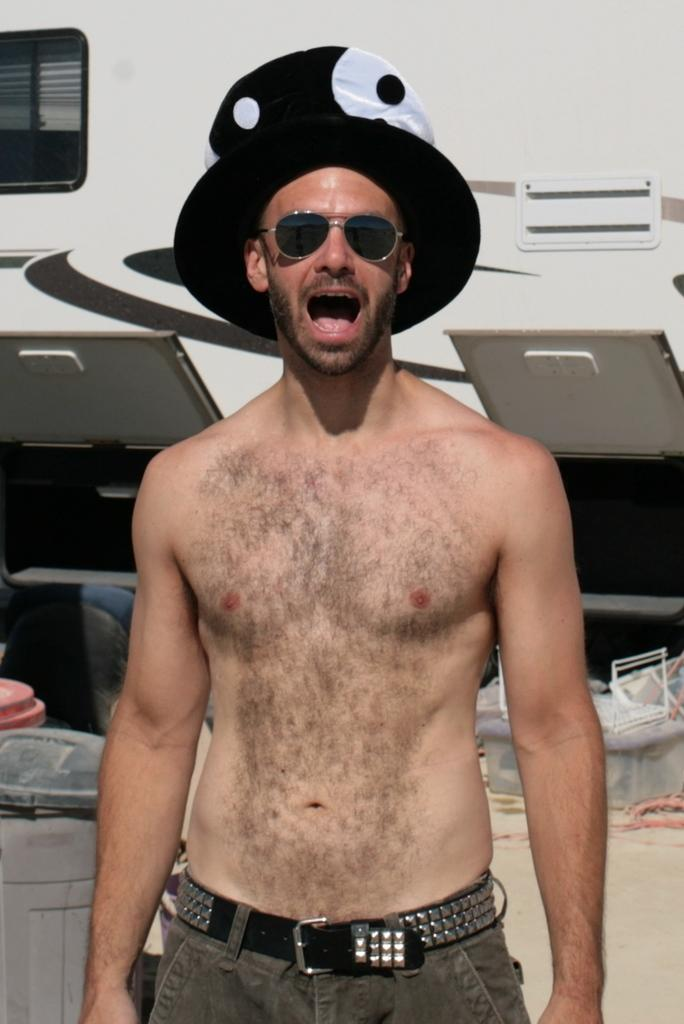Who is present in the image? There is a man in the image. What is the man wearing on his head? The man is wearing a cap. What is the man wearing to protect his eyes? The man is wearing goggles. What is the man's posture in the image? The man is standing. What can be seen in the background of the image? There are bins, a vehicle, and other objects in the background of the image. What type of honey is the man collecting from the tail in the image? There is no honey or tail present in the image. 